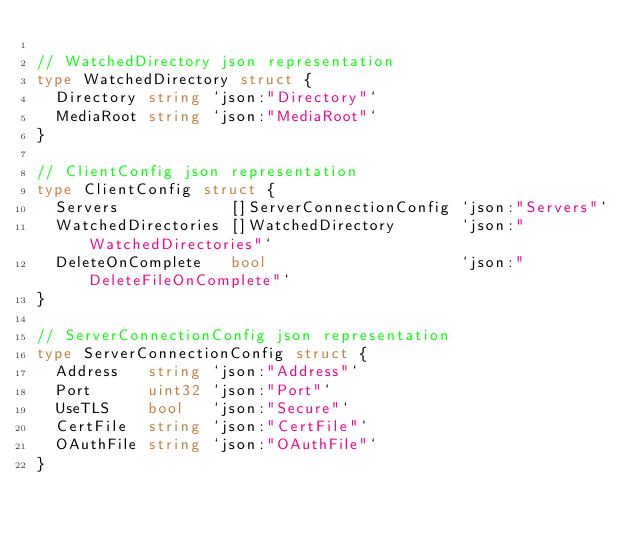<code> <loc_0><loc_0><loc_500><loc_500><_Go_>
// WatchedDirectory json representation
type WatchedDirectory struct {
	Directory string `json:"Directory"`
	MediaRoot string `json:"MediaRoot"`
}

// ClientConfig json representation
type ClientConfig struct {
	Servers            []ServerConnectionConfig `json:"Servers"`
	WatchedDirectories []WatchedDirectory       `json:"WatchedDirectories"`
	DeleteOnComplete   bool                     `json:"DeleteFileOnComplete"`
}

// ServerConnectionConfig json representation
type ServerConnectionConfig struct {
	Address   string `json:"Address"`
	Port      uint32 `json:"Port"`
	UseTLS    bool   `json:"Secure"`
	CertFile  string `json:"CertFile"`
	OAuthFile string `json:"OAuthFile"`
}
</code> 